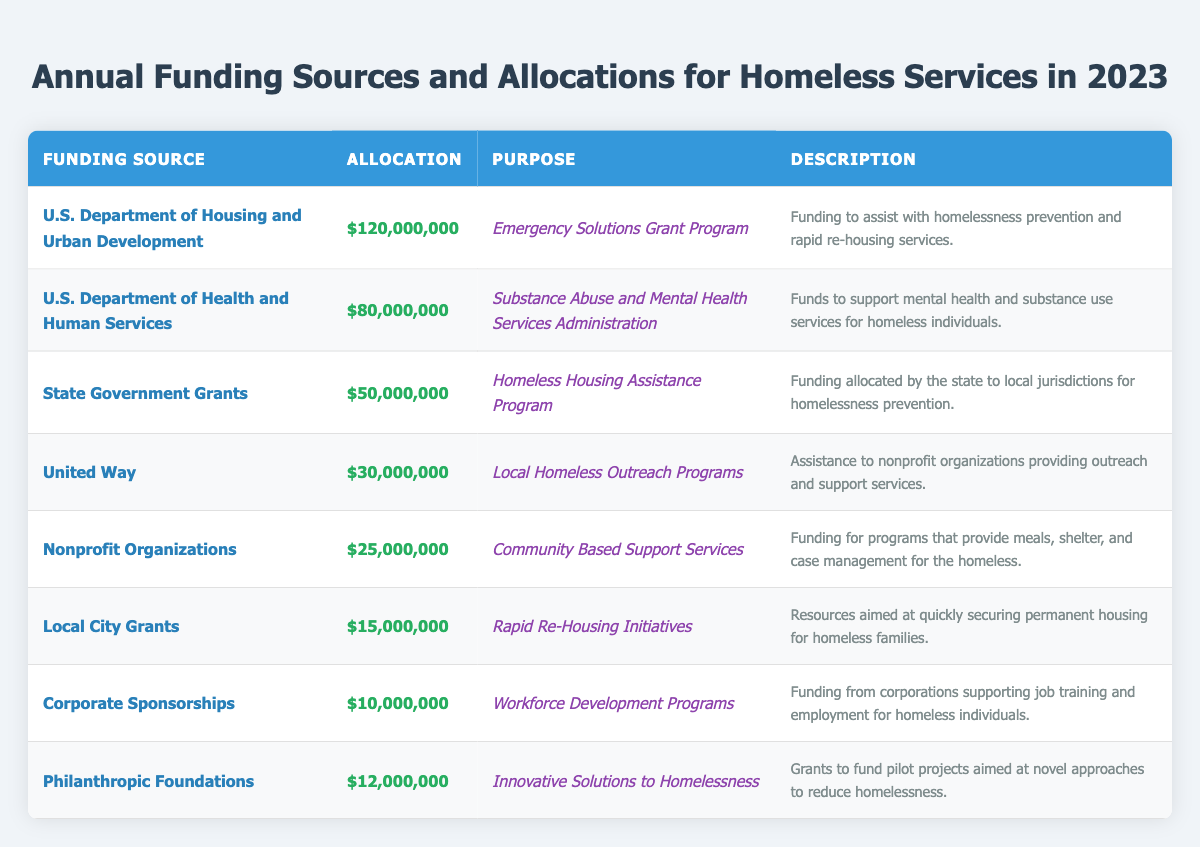What is the total allocation for all funding sources? To find the total allocation, add up all the individual allocations: 120,000,000 + 80,000,000 + 50,000,000 + 30,000,000 + 25,000,000 + 15,000,000 + 10,000,000 + 12,000,000 = 322,000,000.
Answer: 322,000,000 Which funding source has the highest allocation? The table shows that the U.S. Department of Housing and Urban Development has the highest allocation at 120,000,000.
Answer: U.S. Department of Housing and Urban Development Is the allocation for United Way greater than the allocation for Local City Grants? The allocation for United Way is 30,000,000, while Local City Grants has 15,000,000. Since 30,000,000 is greater than 15,000,000, the statement is true.
Answer: Yes What is the sum of the allocations for Nonprofit Organizations and Corporate Sponsorships? The allocation for Nonprofit Organizations is 25,000,000 and for Corporate Sponsorships is 10,000,000. Adding them gives: 25,000,000 + 10,000,000 = 35,000,000.
Answer: 35,000,000 How much funding is allocated for programs specifically aimed at employment and job training? The funding aimed at employment and job training is from Corporate Sponsorships, totaling 10,000,000.
Answer: 10,000,000 Which funding source provides support for mental health services? The U.S. Department of Health and Human Services allocates 80,000,000 specifically to support mental health and substance use services for homeless individuals.
Answer: U.S. Department of Health and Human Services What is the average allocation across all funding sources? There are 8 funding sources, and the total allocation is 322,000,000. To find the average, divide 322,000,000 by 8: 322,000,000 / 8 = 40,250,000.
Answer: 40,250,000 Do Philanthropic Foundations provide more funding than Corporate Sponsorships? Philanthropic Foundations allocate 12,000,000 while Corporate Sponsorships allocate 10,000,000. Since 12,000,000 is greater than 10,000,000, the statement is true.
Answer: Yes Which funding source focuses on innovative solutions to homelessness? Philanthropic Foundations focus on innovative solutions to homelessness, with an allocation of 12,000,000.
Answer: Philanthropic Foundations What is the difference between the allocations for State Government Grants and Nonprofit Organizations? The allocation for State Government Grants is 50,000,000 and for Nonprofit Organizations is 25,000,000. The difference is 50,000,000 - 25,000,000 = 25,000,000.
Answer: 25,000,000 What percentage of the total funding does the Emergency Solutions Grant Program receive? The allocation for the Emergency Solutions Grant Program is 120,000,000. To find the percentage, divide by the total allocation: (120,000,000 / 322,000,000) * 100 ≈ 37.3%.
Answer: 37.3% 